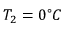Convert formula to latex. <formula><loc_0><loc_0><loc_500><loc_500>T _ { 2 } = 0 ^ { \circ } C</formula> 